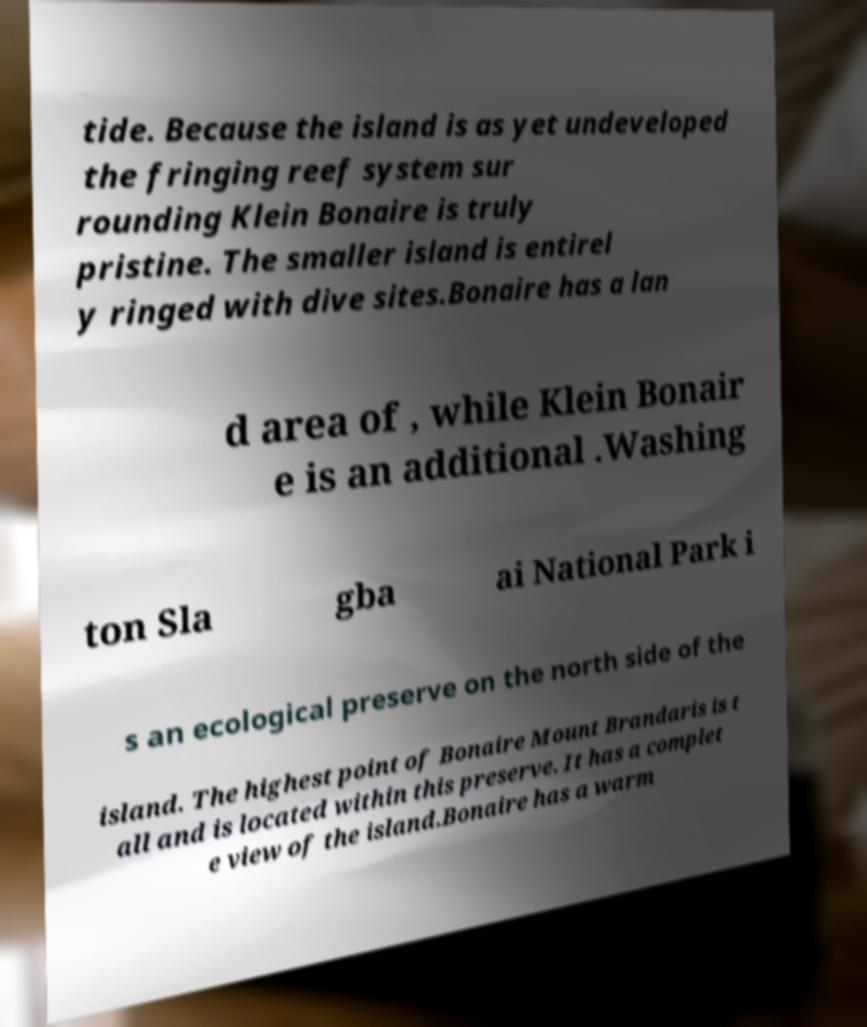Please identify and transcribe the text found in this image. tide. Because the island is as yet undeveloped the fringing reef system sur rounding Klein Bonaire is truly pristine. The smaller island is entirel y ringed with dive sites.Bonaire has a lan d area of , while Klein Bonair e is an additional .Washing ton Sla gba ai National Park i s an ecological preserve on the north side of the island. The highest point of Bonaire Mount Brandaris is t all and is located within this preserve. It has a complet e view of the island.Bonaire has a warm 